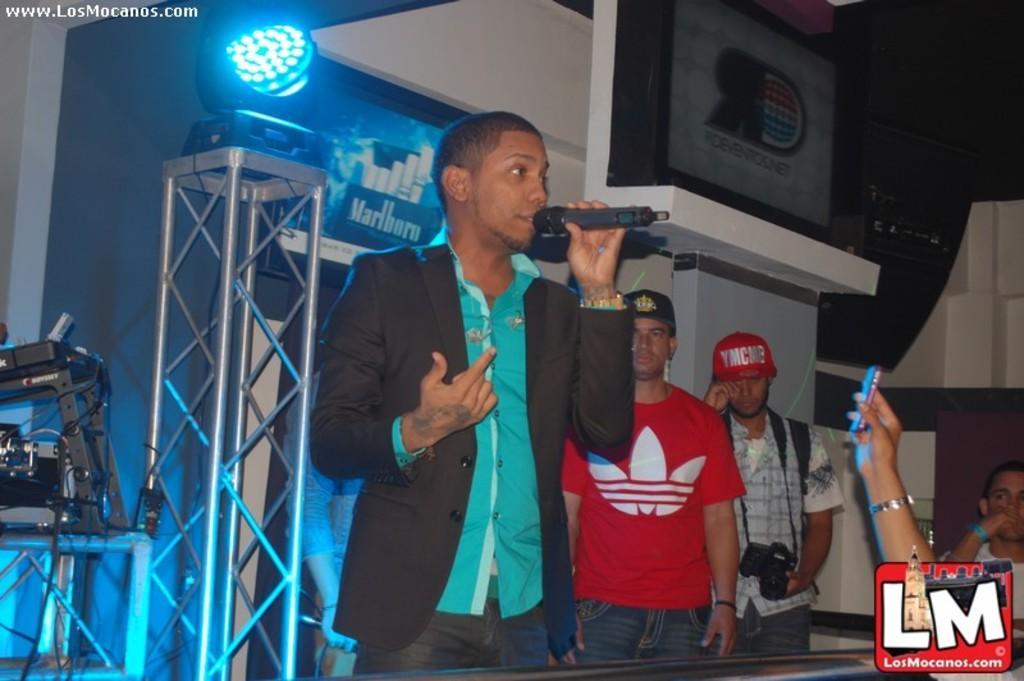Please provide a concise description of this image. In this image there are people standing and one man is holding mic, in the background there is a light on a iron stand, in the bottom right there is a logo. 